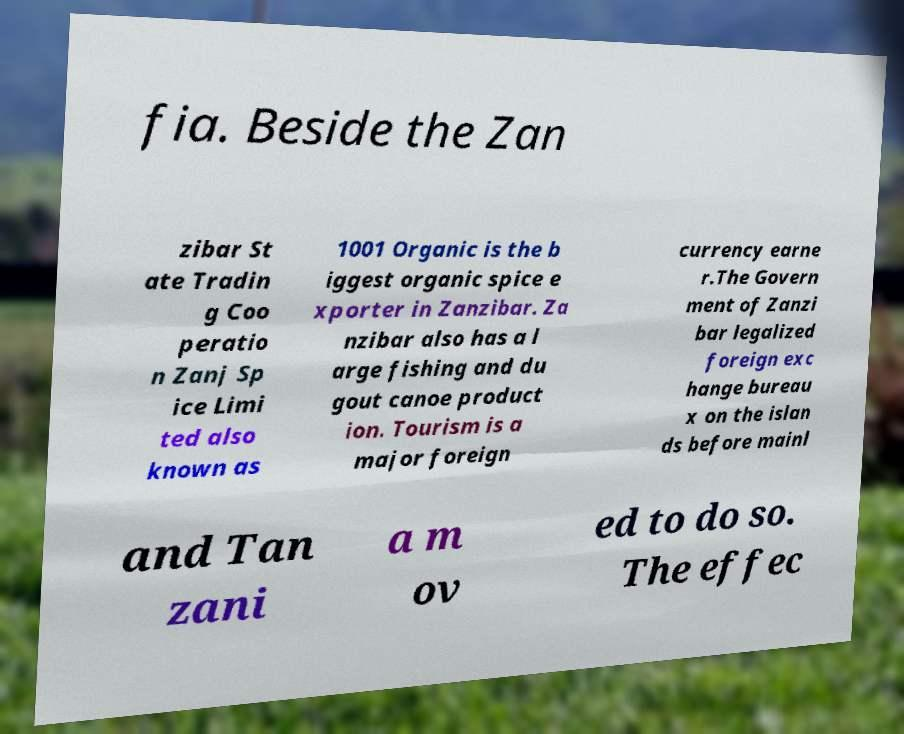Could you extract and type out the text from this image? fia. Beside the Zan zibar St ate Tradin g Coo peratio n Zanj Sp ice Limi ted also known as 1001 Organic is the b iggest organic spice e xporter in Zanzibar. Za nzibar also has a l arge fishing and du gout canoe product ion. Tourism is a major foreign currency earne r.The Govern ment of Zanzi bar legalized foreign exc hange bureau x on the islan ds before mainl and Tan zani a m ov ed to do so. The effec 